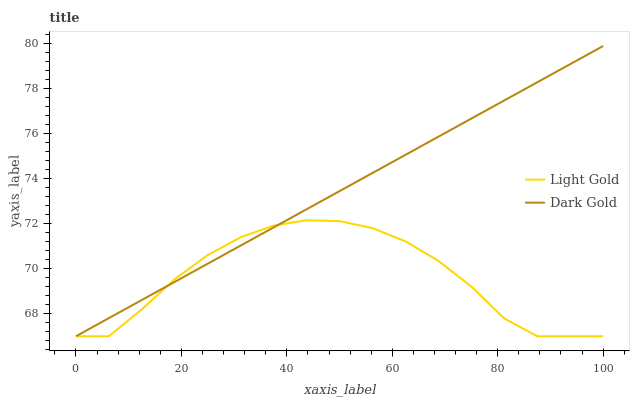Does Light Gold have the minimum area under the curve?
Answer yes or no. Yes. Does Dark Gold have the maximum area under the curve?
Answer yes or no. Yes. Does Dark Gold have the minimum area under the curve?
Answer yes or no. No. Is Dark Gold the smoothest?
Answer yes or no. Yes. Is Light Gold the roughest?
Answer yes or no. Yes. Is Dark Gold the roughest?
Answer yes or no. No. Does Light Gold have the lowest value?
Answer yes or no. Yes. Does Dark Gold have the highest value?
Answer yes or no. Yes. Does Dark Gold intersect Light Gold?
Answer yes or no. Yes. Is Dark Gold less than Light Gold?
Answer yes or no. No. Is Dark Gold greater than Light Gold?
Answer yes or no. No. 